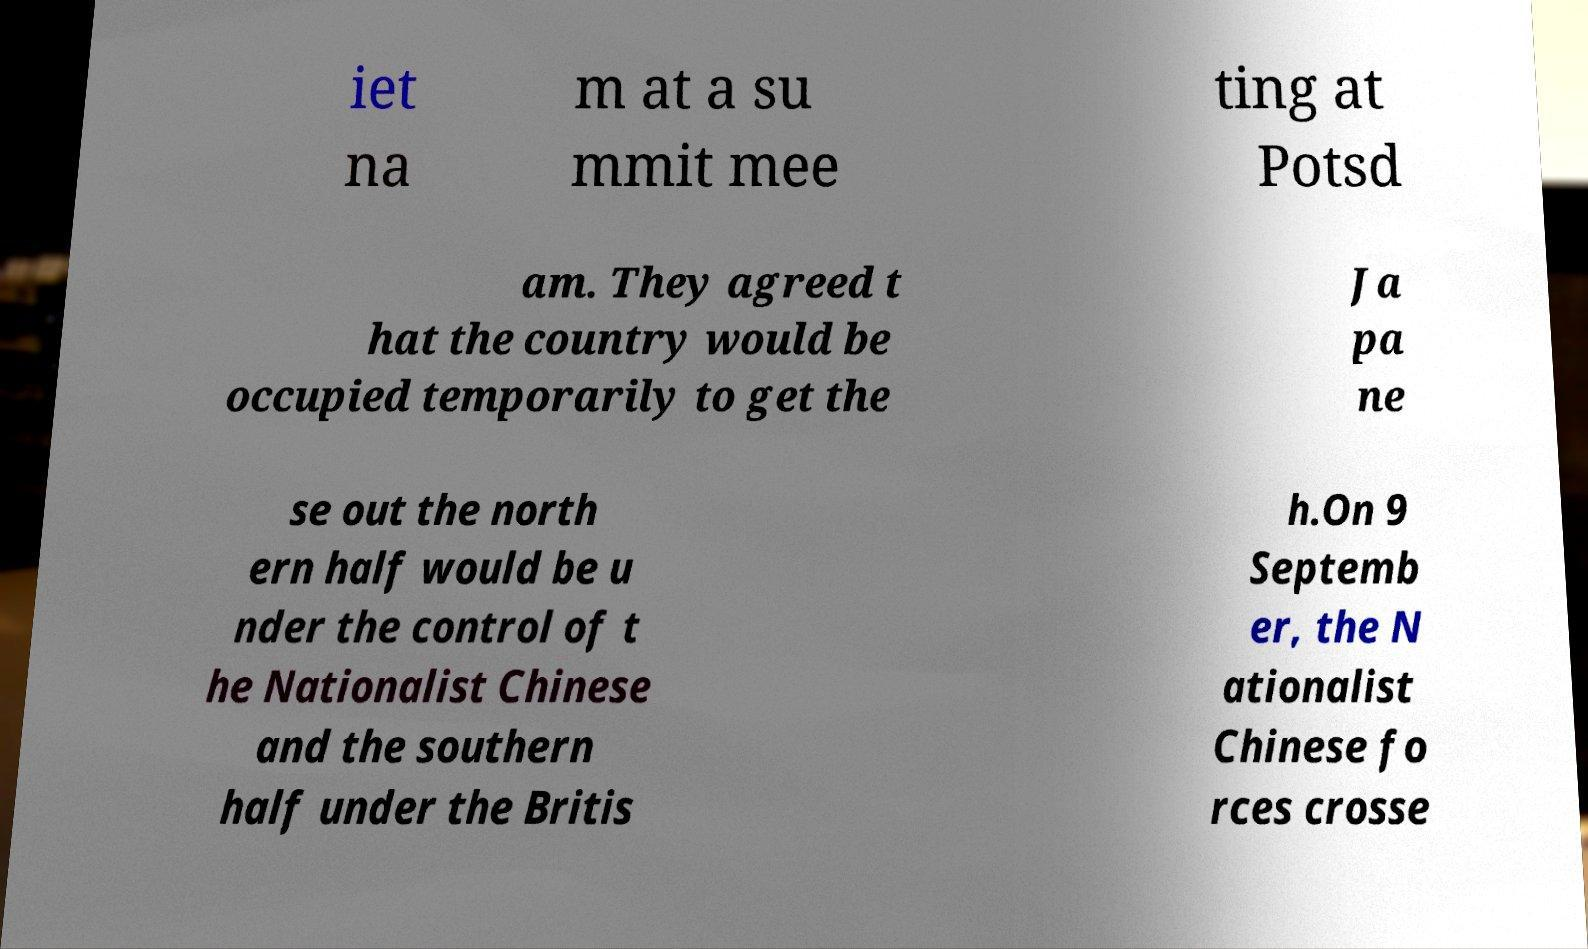There's text embedded in this image that I need extracted. Can you transcribe it verbatim? iet na m at a su mmit mee ting at Potsd am. They agreed t hat the country would be occupied temporarily to get the Ja pa ne se out the north ern half would be u nder the control of t he Nationalist Chinese and the southern half under the Britis h.On 9 Septemb er, the N ationalist Chinese fo rces crosse 